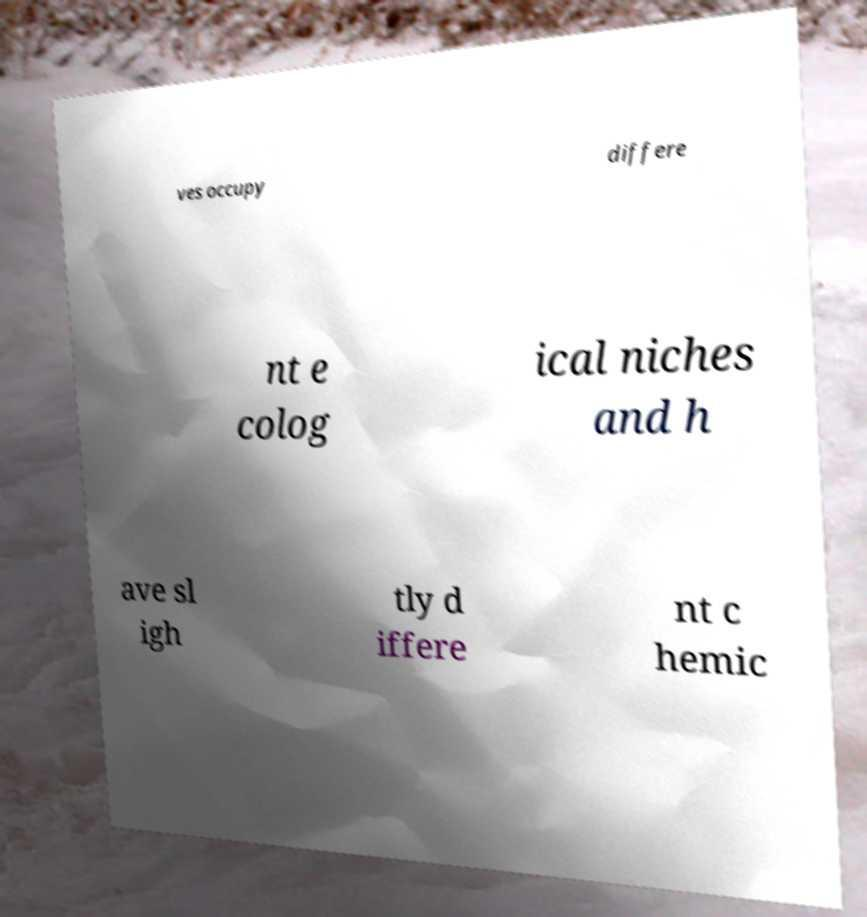Can you accurately transcribe the text from the provided image for me? ves occupy differe nt e colog ical niches and h ave sl igh tly d iffere nt c hemic 